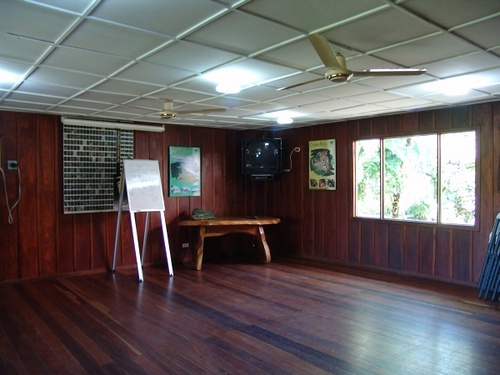Describe the objects in this image and their specific colors. I can see dining table in gray, black, and maroon tones, tv in gray, black, blue, and darkblue tones, and chair in gray, navy, blue, and black tones in this image. 